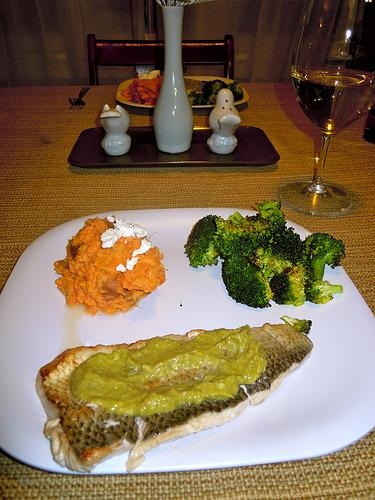Detail the different items found in the image connected to food and dining. The image presents a plate with fish topped with a mustard sauce, mashed sweet potatoes with a topping, broccoli, a glass of white wine, and salt and pepper shakers. Mention the type of setting the image seems to display. The image portrays a home dining setting with a dinner plate, glassware, and salt and pepper shakers on a table with a tablecloth. Enumerate the major objects seen in the image. Fish with mustard sauce on a plate, mashed sweet potatoes, broccoli, a glass of white wine, salt and pepper shakers, and a tablecloth. Describe the objects found in the image related to dining. The image features a dinner plate with fish, mustard sauce, mashed sweet potatoes, broccoli, a glass of white wine, and salt and pepper shakers. Describe the various items found on the table in the image. There are plates with fish, mustard sauce, mashed sweet potatoes, broccoli, a glass of white wine, salt and pepper shakers, and a tablecloth. Name the different pieces of tableware seen in the image. White dinner plate, glass of white wine, salt and pepper shakers, and a tablecloth. Mention the primary focus of the image and its features. The image showcases a meal served on a white plate with fish topped with mustard sauce, mashed sweet potatoes, and broccoli, accompanied by a glass of white wine. Summarize the main elements of the image in a sentence. A nutritious dinner featuring fish with mustard sauce, mashed sweet potatoes, broccoli, and a glass of white wine is served on a table. What is the main food item in the image and how is it served? The main food item is fish served with a mustard sauce on a white plate, accompanied by mashed sweet potatoes and broccoli. Briefly describe the main components of the image in a casual tone. There's a tasty-looking fish dish with mustard sauce, mashed sweet potatoes, and broccoli on a plate, paired with a glass of white wine. 